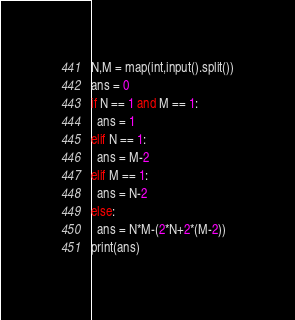Convert code to text. <code><loc_0><loc_0><loc_500><loc_500><_Python_>N,M = map(int,input().split())
ans = 0
if N == 1 and M == 1:
  ans = 1
elif N == 1:
  ans = M-2
elif M == 1:
  ans = N-2
else:
  ans = N*M-(2*N+2*(M-2))
print(ans)</code> 